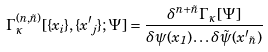<formula> <loc_0><loc_0><loc_500><loc_500>\Gamma ^ { ( n , \tilde { n } ) } _ { \kappa } [ \{ { x } _ { i } \} , \{ { x ^ { \prime } } _ { j } \} ; \Psi ] = \frac { \delta ^ { n + \tilde { n } } \Gamma _ { \kappa } [ \Psi ] } { \delta \psi ( { x } _ { 1 } ) \dots \delta \tilde { \psi } ( { x ^ { \prime } } _ { \tilde { n } } ) }</formula> 